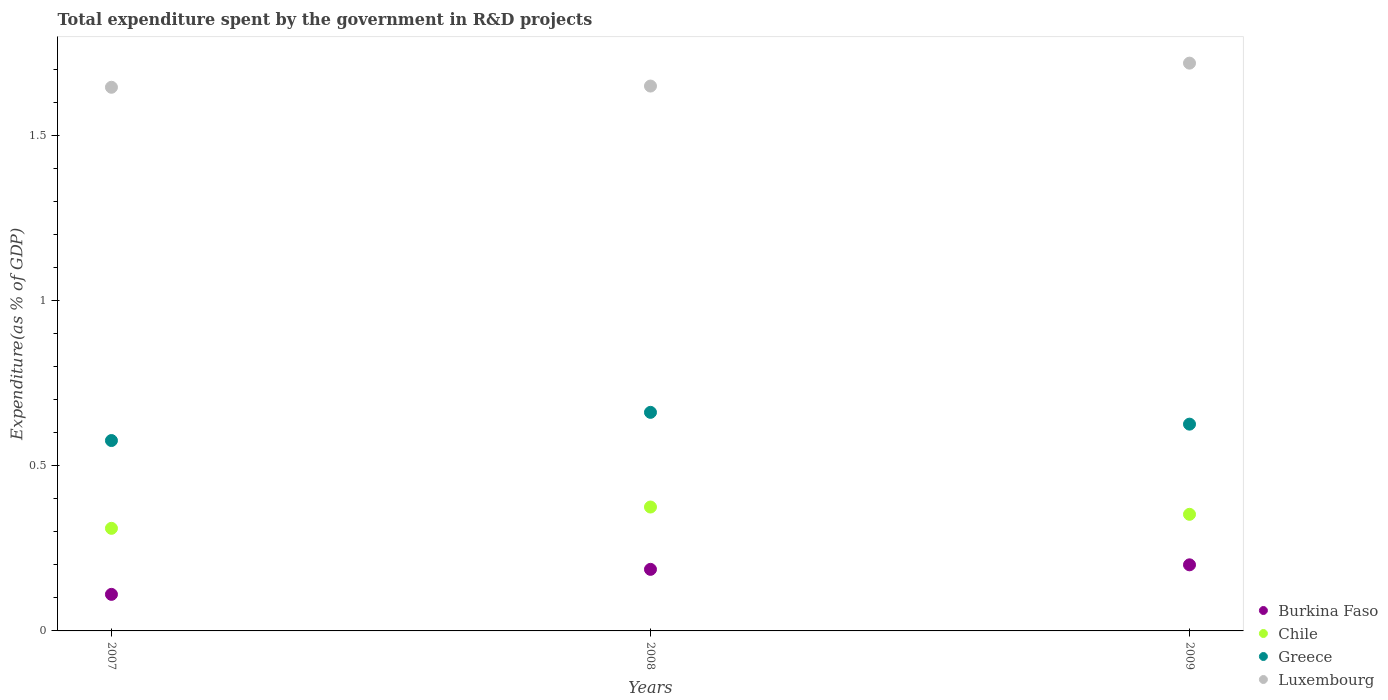How many different coloured dotlines are there?
Offer a terse response. 4. Is the number of dotlines equal to the number of legend labels?
Provide a succinct answer. Yes. What is the total expenditure spent by the government in R&D projects in Greece in 2008?
Give a very brief answer. 0.66. Across all years, what is the maximum total expenditure spent by the government in R&D projects in Greece?
Your response must be concise. 0.66. Across all years, what is the minimum total expenditure spent by the government in R&D projects in Greece?
Offer a terse response. 0.58. In which year was the total expenditure spent by the government in R&D projects in Chile maximum?
Offer a very short reply. 2008. What is the total total expenditure spent by the government in R&D projects in Luxembourg in the graph?
Your answer should be very brief. 5.01. What is the difference between the total expenditure spent by the government in R&D projects in Greece in 2008 and that in 2009?
Your answer should be very brief. 0.04. What is the difference between the total expenditure spent by the government in R&D projects in Greece in 2009 and the total expenditure spent by the government in R&D projects in Luxembourg in 2008?
Keep it short and to the point. -1.02. What is the average total expenditure spent by the government in R&D projects in Greece per year?
Provide a short and direct response. 0.62. In the year 2007, what is the difference between the total expenditure spent by the government in R&D projects in Chile and total expenditure spent by the government in R&D projects in Greece?
Keep it short and to the point. -0.27. In how many years, is the total expenditure spent by the government in R&D projects in Greece greater than 0.4 %?
Your response must be concise. 3. What is the ratio of the total expenditure spent by the government in R&D projects in Chile in 2008 to that in 2009?
Your response must be concise. 1.06. What is the difference between the highest and the second highest total expenditure spent by the government in R&D projects in Chile?
Provide a short and direct response. 0.02. What is the difference between the highest and the lowest total expenditure spent by the government in R&D projects in Chile?
Make the answer very short. 0.06. Does the total expenditure spent by the government in R&D projects in Burkina Faso monotonically increase over the years?
Provide a succinct answer. Yes. Is the total expenditure spent by the government in R&D projects in Greece strictly greater than the total expenditure spent by the government in R&D projects in Luxembourg over the years?
Your response must be concise. No. How many years are there in the graph?
Provide a short and direct response. 3. Does the graph contain any zero values?
Your response must be concise. No. Does the graph contain grids?
Offer a very short reply. No. How are the legend labels stacked?
Your answer should be compact. Vertical. What is the title of the graph?
Your response must be concise. Total expenditure spent by the government in R&D projects. Does "South Africa" appear as one of the legend labels in the graph?
Provide a short and direct response. No. What is the label or title of the Y-axis?
Provide a succinct answer. Expenditure(as % of GDP). What is the Expenditure(as % of GDP) in Burkina Faso in 2007?
Keep it short and to the point. 0.11. What is the Expenditure(as % of GDP) in Chile in 2007?
Give a very brief answer. 0.31. What is the Expenditure(as % of GDP) in Greece in 2007?
Give a very brief answer. 0.58. What is the Expenditure(as % of GDP) of Luxembourg in 2007?
Your answer should be very brief. 1.65. What is the Expenditure(as % of GDP) in Burkina Faso in 2008?
Ensure brevity in your answer.  0.19. What is the Expenditure(as % of GDP) in Chile in 2008?
Your response must be concise. 0.37. What is the Expenditure(as % of GDP) in Greece in 2008?
Your answer should be compact. 0.66. What is the Expenditure(as % of GDP) in Luxembourg in 2008?
Offer a very short reply. 1.65. What is the Expenditure(as % of GDP) of Burkina Faso in 2009?
Make the answer very short. 0.2. What is the Expenditure(as % of GDP) of Chile in 2009?
Your response must be concise. 0.35. What is the Expenditure(as % of GDP) in Greece in 2009?
Keep it short and to the point. 0.63. What is the Expenditure(as % of GDP) of Luxembourg in 2009?
Offer a terse response. 1.72. Across all years, what is the maximum Expenditure(as % of GDP) in Burkina Faso?
Make the answer very short. 0.2. Across all years, what is the maximum Expenditure(as % of GDP) in Chile?
Make the answer very short. 0.37. Across all years, what is the maximum Expenditure(as % of GDP) of Greece?
Offer a terse response. 0.66. Across all years, what is the maximum Expenditure(as % of GDP) in Luxembourg?
Your response must be concise. 1.72. Across all years, what is the minimum Expenditure(as % of GDP) of Burkina Faso?
Your answer should be compact. 0.11. Across all years, what is the minimum Expenditure(as % of GDP) in Chile?
Your answer should be very brief. 0.31. Across all years, what is the minimum Expenditure(as % of GDP) of Greece?
Keep it short and to the point. 0.58. Across all years, what is the minimum Expenditure(as % of GDP) of Luxembourg?
Your response must be concise. 1.65. What is the total Expenditure(as % of GDP) of Burkina Faso in the graph?
Give a very brief answer. 0.5. What is the total Expenditure(as % of GDP) of Chile in the graph?
Provide a succinct answer. 1.04. What is the total Expenditure(as % of GDP) of Greece in the graph?
Your response must be concise. 1.86. What is the total Expenditure(as % of GDP) of Luxembourg in the graph?
Your answer should be compact. 5.01. What is the difference between the Expenditure(as % of GDP) of Burkina Faso in 2007 and that in 2008?
Your answer should be very brief. -0.08. What is the difference between the Expenditure(as % of GDP) of Chile in 2007 and that in 2008?
Offer a very short reply. -0.06. What is the difference between the Expenditure(as % of GDP) in Greece in 2007 and that in 2008?
Your answer should be very brief. -0.09. What is the difference between the Expenditure(as % of GDP) in Luxembourg in 2007 and that in 2008?
Provide a succinct answer. -0. What is the difference between the Expenditure(as % of GDP) in Burkina Faso in 2007 and that in 2009?
Provide a succinct answer. -0.09. What is the difference between the Expenditure(as % of GDP) of Chile in 2007 and that in 2009?
Provide a short and direct response. -0.04. What is the difference between the Expenditure(as % of GDP) in Greece in 2007 and that in 2009?
Provide a succinct answer. -0.05. What is the difference between the Expenditure(as % of GDP) of Luxembourg in 2007 and that in 2009?
Make the answer very short. -0.07. What is the difference between the Expenditure(as % of GDP) of Burkina Faso in 2008 and that in 2009?
Give a very brief answer. -0.01. What is the difference between the Expenditure(as % of GDP) in Chile in 2008 and that in 2009?
Provide a short and direct response. 0.02. What is the difference between the Expenditure(as % of GDP) of Greece in 2008 and that in 2009?
Make the answer very short. 0.04. What is the difference between the Expenditure(as % of GDP) of Luxembourg in 2008 and that in 2009?
Offer a very short reply. -0.07. What is the difference between the Expenditure(as % of GDP) of Burkina Faso in 2007 and the Expenditure(as % of GDP) of Chile in 2008?
Your answer should be very brief. -0.26. What is the difference between the Expenditure(as % of GDP) of Burkina Faso in 2007 and the Expenditure(as % of GDP) of Greece in 2008?
Your answer should be compact. -0.55. What is the difference between the Expenditure(as % of GDP) of Burkina Faso in 2007 and the Expenditure(as % of GDP) of Luxembourg in 2008?
Give a very brief answer. -1.54. What is the difference between the Expenditure(as % of GDP) in Chile in 2007 and the Expenditure(as % of GDP) in Greece in 2008?
Make the answer very short. -0.35. What is the difference between the Expenditure(as % of GDP) in Chile in 2007 and the Expenditure(as % of GDP) in Luxembourg in 2008?
Your answer should be very brief. -1.34. What is the difference between the Expenditure(as % of GDP) of Greece in 2007 and the Expenditure(as % of GDP) of Luxembourg in 2008?
Offer a terse response. -1.07. What is the difference between the Expenditure(as % of GDP) in Burkina Faso in 2007 and the Expenditure(as % of GDP) in Chile in 2009?
Offer a very short reply. -0.24. What is the difference between the Expenditure(as % of GDP) in Burkina Faso in 2007 and the Expenditure(as % of GDP) in Greece in 2009?
Ensure brevity in your answer.  -0.52. What is the difference between the Expenditure(as % of GDP) of Burkina Faso in 2007 and the Expenditure(as % of GDP) of Luxembourg in 2009?
Provide a succinct answer. -1.61. What is the difference between the Expenditure(as % of GDP) of Chile in 2007 and the Expenditure(as % of GDP) of Greece in 2009?
Keep it short and to the point. -0.32. What is the difference between the Expenditure(as % of GDP) in Chile in 2007 and the Expenditure(as % of GDP) in Luxembourg in 2009?
Keep it short and to the point. -1.41. What is the difference between the Expenditure(as % of GDP) of Greece in 2007 and the Expenditure(as % of GDP) of Luxembourg in 2009?
Provide a succinct answer. -1.14. What is the difference between the Expenditure(as % of GDP) of Burkina Faso in 2008 and the Expenditure(as % of GDP) of Chile in 2009?
Give a very brief answer. -0.17. What is the difference between the Expenditure(as % of GDP) of Burkina Faso in 2008 and the Expenditure(as % of GDP) of Greece in 2009?
Make the answer very short. -0.44. What is the difference between the Expenditure(as % of GDP) of Burkina Faso in 2008 and the Expenditure(as % of GDP) of Luxembourg in 2009?
Offer a terse response. -1.53. What is the difference between the Expenditure(as % of GDP) of Chile in 2008 and the Expenditure(as % of GDP) of Greece in 2009?
Keep it short and to the point. -0.25. What is the difference between the Expenditure(as % of GDP) in Chile in 2008 and the Expenditure(as % of GDP) in Luxembourg in 2009?
Provide a short and direct response. -1.34. What is the difference between the Expenditure(as % of GDP) of Greece in 2008 and the Expenditure(as % of GDP) of Luxembourg in 2009?
Offer a terse response. -1.06. What is the average Expenditure(as % of GDP) in Burkina Faso per year?
Ensure brevity in your answer.  0.17. What is the average Expenditure(as % of GDP) in Chile per year?
Offer a terse response. 0.35. What is the average Expenditure(as % of GDP) of Greece per year?
Your response must be concise. 0.62. What is the average Expenditure(as % of GDP) of Luxembourg per year?
Offer a terse response. 1.67. In the year 2007, what is the difference between the Expenditure(as % of GDP) in Burkina Faso and Expenditure(as % of GDP) in Chile?
Your answer should be very brief. -0.2. In the year 2007, what is the difference between the Expenditure(as % of GDP) of Burkina Faso and Expenditure(as % of GDP) of Greece?
Ensure brevity in your answer.  -0.47. In the year 2007, what is the difference between the Expenditure(as % of GDP) of Burkina Faso and Expenditure(as % of GDP) of Luxembourg?
Offer a very short reply. -1.53. In the year 2007, what is the difference between the Expenditure(as % of GDP) of Chile and Expenditure(as % of GDP) of Greece?
Offer a terse response. -0.27. In the year 2007, what is the difference between the Expenditure(as % of GDP) in Chile and Expenditure(as % of GDP) in Luxembourg?
Provide a short and direct response. -1.33. In the year 2007, what is the difference between the Expenditure(as % of GDP) in Greece and Expenditure(as % of GDP) in Luxembourg?
Provide a succinct answer. -1.07. In the year 2008, what is the difference between the Expenditure(as % of GDP) in Burkina Faso and Expenditure(as % of GDP) in Chile?
Ensure brevity in your answer.  -0.19. In the year 2008, what is the difference between the Expenditure(as % of GDP) of Burkina Faso and Expenditure(as % of GDP) of Greece?
Provide a succinct answer. -0.48. In the year 2008, what is the difference between the Expenditure(as % of GDP) of Burkina Faso and Expenditure(as % of GDP) of Luxembourg?
Provide a short and direct response. -1.46. In the year 2008, what is the difference between the Expenditure(as % of GDP) of Chile and Expenditure(as % of GDP) of Greece?
Ensure brevity in your answer.  -0.29. In the year 2008, what is the difference between the Expenditure(as % of GDP) in Chile and Expenditure(as % of GDP) in Luxembourg?
Make the answer very short. -1.27. In the year 2008, what is the difference between the Expenditure(as % of GDP) of Greece and Expenditure(as % of GDP) of Luxembourg?
Provide a succinct answer. -0.99. In the year 2009, what is the difference between the Expenditure(as % of GDP) of Burkina Faso and Expenditure(as % of GDP) of Chile?
Offer a terse response. -0.15. In the year 2009, what is the difference between the Expenditure(as % of GDP) in Burkina Faso and Expenditure(as % of GDP) in Greece?
Your answer should be compact. -0.43. In the year 2009, what is the difference between the Expenditure(as % of GDP) in Burkina Faso and Expenditure(as % of GDP) in Luxembourg?
Provide a short and direct response. -1.52. In the year 2009, what is the difference between the Expenditure(as % of GDP) in Chile and Expenditure(as % of GDP) in Greece?
Keep it short and to the point. -0.27. In the year 2009, what is the difference between the Expenditure(as % of GDP) of Chile and Expenditure(as % of GDP) of Luxembourg?
Provide a succinct answer. -1.37. In the year 2009, what is the difference between the Expenditure(as % of GDP) in Greece and Expenditure(as % of GDP) in Luxembourg?
Ensure brevity in your answer.  -1.09. What is the ratio of the Expenditure(as % of GDP) in Burkina Faso in 2007 to that in 2008?
Make the answer very short. 0.59. What is the ratio of the Expenditure(as % of GDP) in Chile in 2007 to that in 2008?
Make the answer very short. 0.83. What is the ratio of the Expenditure(as % of GDP) in Greece in 2007 to that in 2008?
Give a very brief answer. 0.87. What is the ratio of the Expenditure(as % of GDP) of Burkina Faso in 2007 to that in 2009?
Make the answer very short. 0.55. What is the ratio of the Expenditure(as % of GDP) in Chile in 2007 to that in 2009?
Keep it short and to the point. 0.88. What is the ratio of the Expenditure(as % of GDP) in Greece in 2007 to that in 2009?
Give a very brief answer. 0.92. What is the ratio of the Expenditure(as % of GDP) of Luxembourg in 2007 to that in 2009?
Your response must be concise. 0.96. What is the ratio of the Expenditure(as % of GDP) in Burkina Faso in 2008 to that in 2009?
Make the answer very short. 0.93. What is the ratio of the Expenditure(as % of GDP) in Chile in 2008 to that in 2009?
Give a very brief answer. 1.06. What is the ratio of the Expenditure(as % of GDP) in Greece in 2008 to that in 2009?
Ensure brevity in your answer.  1.06. What is the ratio of the Expenditure(as % of GDP) in Luxembourg in 2008 to that in 2009?
Offer a very short reply. 0.96. What is the difference between the highest and the second highest Expenditure(as % of GDP) in Burkina Faso?
Ensure brevity in your answer.  0.01. What is the difference between the highest and the second highest Expenditure(as % of GDP) of Chile?
Ensure brevity in your answer.  0.02. What is the difference between the highest and the second highest Expenditure(as % of GDP) of Greece?
Ensure brevity in your answer.  0.04. What is the difference between the highest and the second highest Expenditure(as % of GDP) in Luxembourg?
Give a very brief answer. 0.07. What is the difference between the highest and the lowest Expenditure(as % of GDP) of Burkina Faso?
Your answer should be compact. 0.09. What is the difference between the highest and the lowest Expenditure(as % of GDP) of Chile?
Offer a very short reply. 0.06. What is the difference between the highest and the lowest Expenditure(as % of GDP) in Greece?
Make the answer very short. 0.09. What is the difference between the highest and the lowest Expenditure(as % of GDP) in Luxembourg?
Make the answer very short. 0.07. 